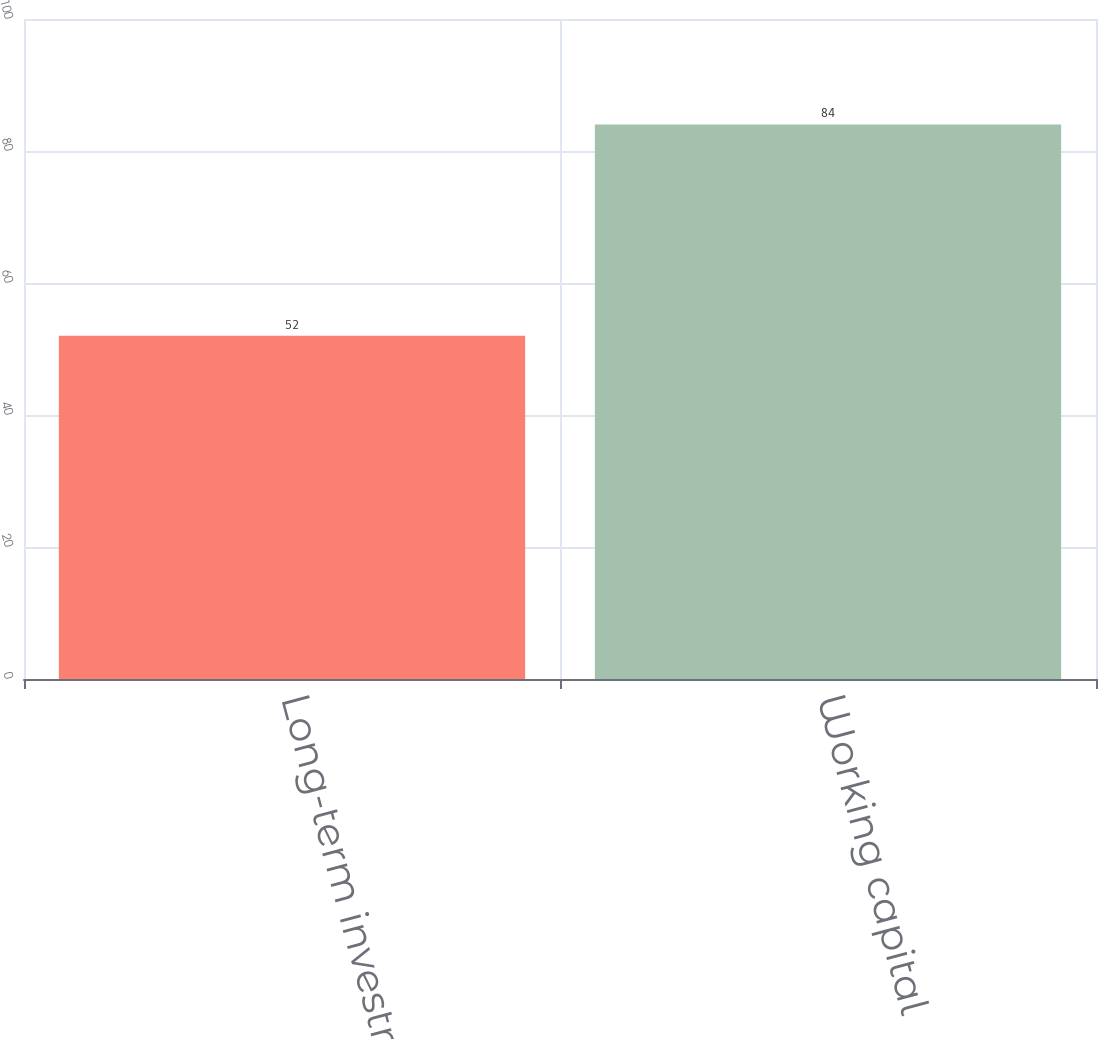Convert chart to OTSL. <chart><loc_0><loc_0><loc_500><loc_500><bar_chart><fcel>Long-term investments<fcel>Working capital<nl><fcel>52<fcel>84<nl></chart> 